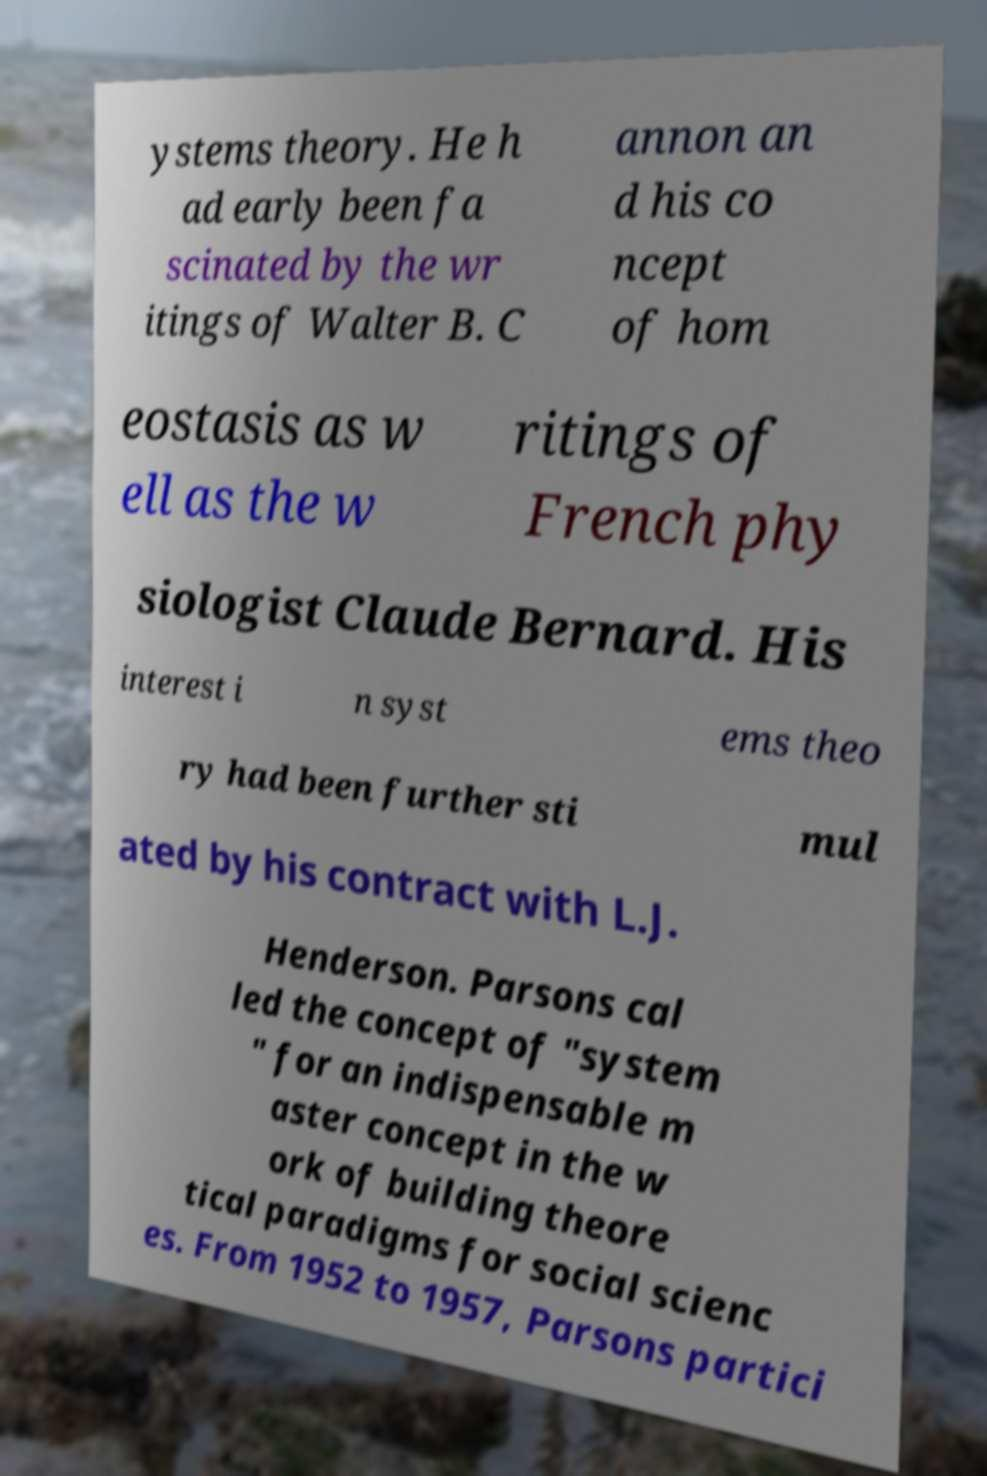Please read and relay the text visible in this image. What does it say? ystems theory. He h ad early been fa scinated by the wr itings of Walter B. C annon an d his co ncept of hom eostasis as w ell as the w ritings of French phy siologist Claude Bernard. His interest i n syst ems theo ry had been further sti mul ated by his contract with L.J. Henderson. Parsons cal led the concept of "system " for an indispensable m aster concept in the w ork of building theore tical paradigms for social scienc es. From 1952 to 1957, Parsons partici 